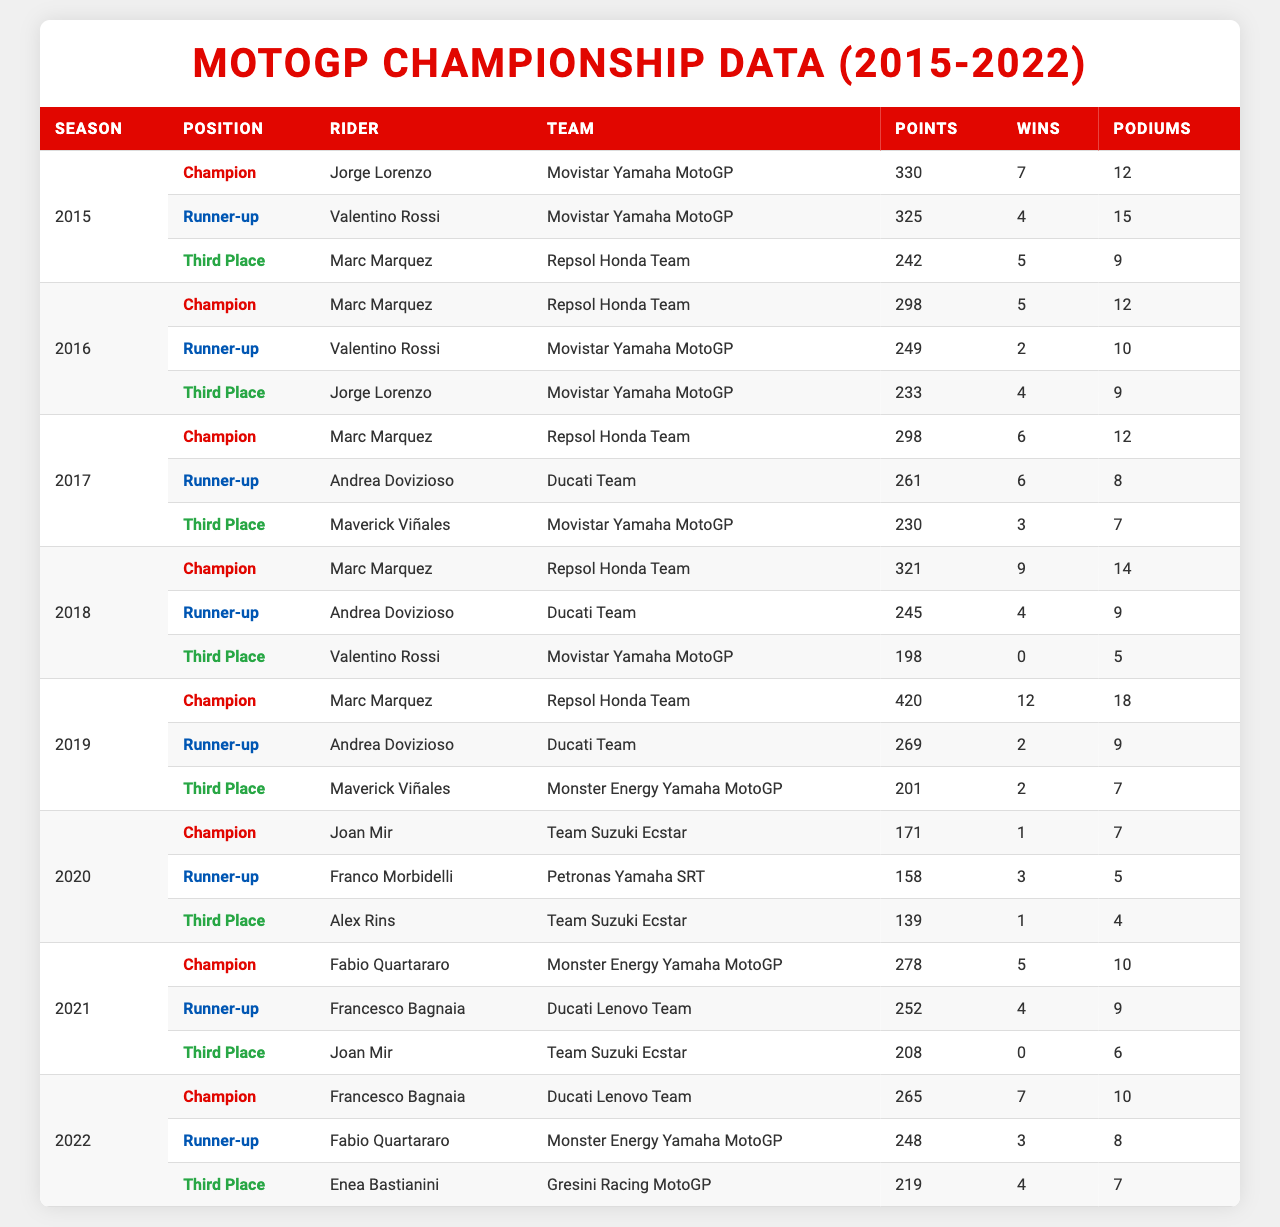What rider won the championship in 2019? The table indicates that the champion of the season 2019 is Marc Marquez from the Repsol Honda Team.
Answer: Marc Marquez How many wins did Joan Mir achieve in his championship year (2020)? Joan Mir, who was the champion in 2020, is noted in the table to have 1 win.
Answer: 1 Which team had the most podium finishes for 2017? In 2017, Marc Marquez achieved 14 podium finishes for the Repsol Honda Team, which is the highest for that year.
Answer: Repsol Honda Team What is the total number of points scored by Andrea Dovizioso across all his seasons from 2015 to 2019? Adding up Dovizioso's points from 2015 (245), 2016 (261), 2017 (269), and 2018 (245) gives (245 + 261 + 269 + 245) = 1020 points.
Answer: 1020 Which rider had the highest total podium finishes across the seasons provided? Behind the table, Marc Marquez has the highest total podium finishes with 14 in 2017 and 18 in 2019, summing up to 32 podiums throughout the seasons provided.
Answer: Marc Marquez Did Valentino Rossi ever win the championship from 2015 to 2022? The table shows that Valentino Rossi was never listed as a champion in any of those seasons.
Answer: No What was the average number of wins for champions from 2015 to 2022? The champions had 7 (Lorenzo) + 5 (Marquez) + 6 (Marquez) + 9 (Marquez) + 12 (Marquez) + 1 (Mir) + 5 (Quartararo) + 7 (Bagnaia) = 53 wins in total; dividing by 8 gives an average of 53/8 = 6.625 wins.
Answer: 6.63 How many podiums did the runner-up of 2021 earn? The table identifies Francesco Bagnaia as the runner-up for 2021 with 9 podium finishes.
Answer: 9 Who achieved the most points as a runner-up in the seasons listed? Analyzing the runner-ups, Andrea Dovizioso had the highest total with 269 points in 2019, which is higher than the other runner-ups.
Answer: Andrea Dovizioso What was the difference in points between the 2018 champion and runner-up? In 2018, Marc Marquez had 321 points as champion, and Andrea Dovizioso had 245 points as runner-up. The difference in points is 321 - 245 = 76.
Answer: 76 